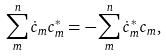Convert formula to latex. <formula><loc_0><loc_0><loc_500><loc_500>\sum _ { m } ^ { n } \dot { c } _ { m } c _ { m } ^ { * } = - \sum _ { m } ^ { n } \dot { c } _ { m } ^ { * } c _ { m } ,</formula> 